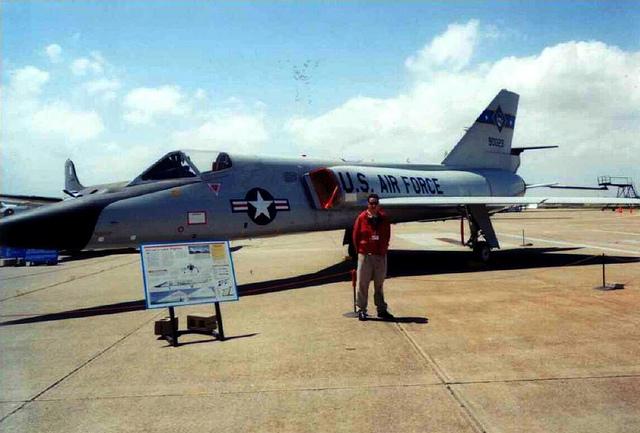Is this plane an exhibit of some kind?
Keep it brief. Yes. What branch of the service is depicted?
Write a very short answer. Air force. What is the color of the strip on the plane?
Quick response, please. White. Is this man flying a jet?
Give a very brief answer. No. 